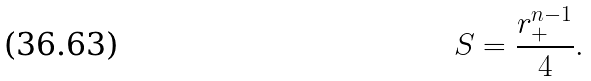Convert formula to latex. <formula><loc_0><loc_0><loc_500><loc_500>S = \frac { r _ { + } ^ { n - 1 } } { 4 } .</formula> 